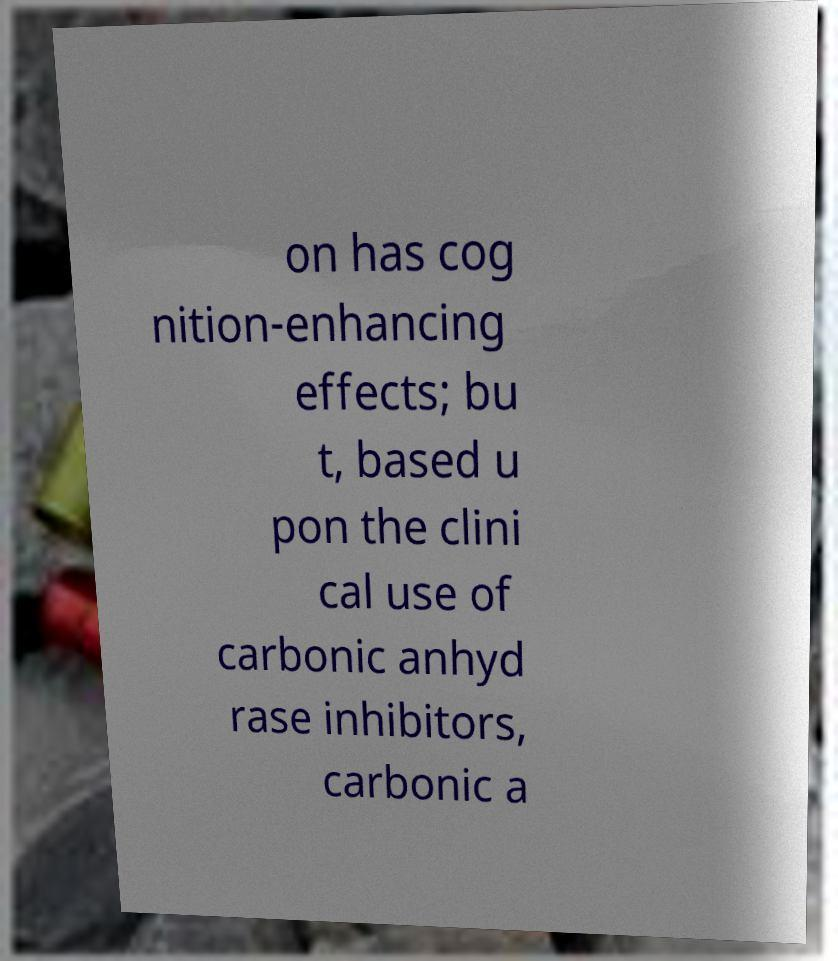For documentation purposes, I need the text within this image transcribed. Could you provide that? on has cog nition-enhancing effects; bu t, based u pon the clini cal use of carbonic anhyd rase inhibitors, carbonic a 